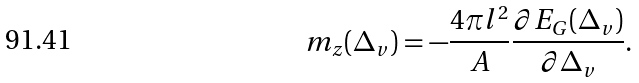<formula> <loc_0><loc_0><loc_500><loc_500>m _ { z } ( \Delta _ { v } ) = - \frac { 4 \pi l ^ { 2 } } { A } \frac { \partial E _ { G } ( \Delta _ { v } ) } { \partial \Delta _ { v } } .</formula> 